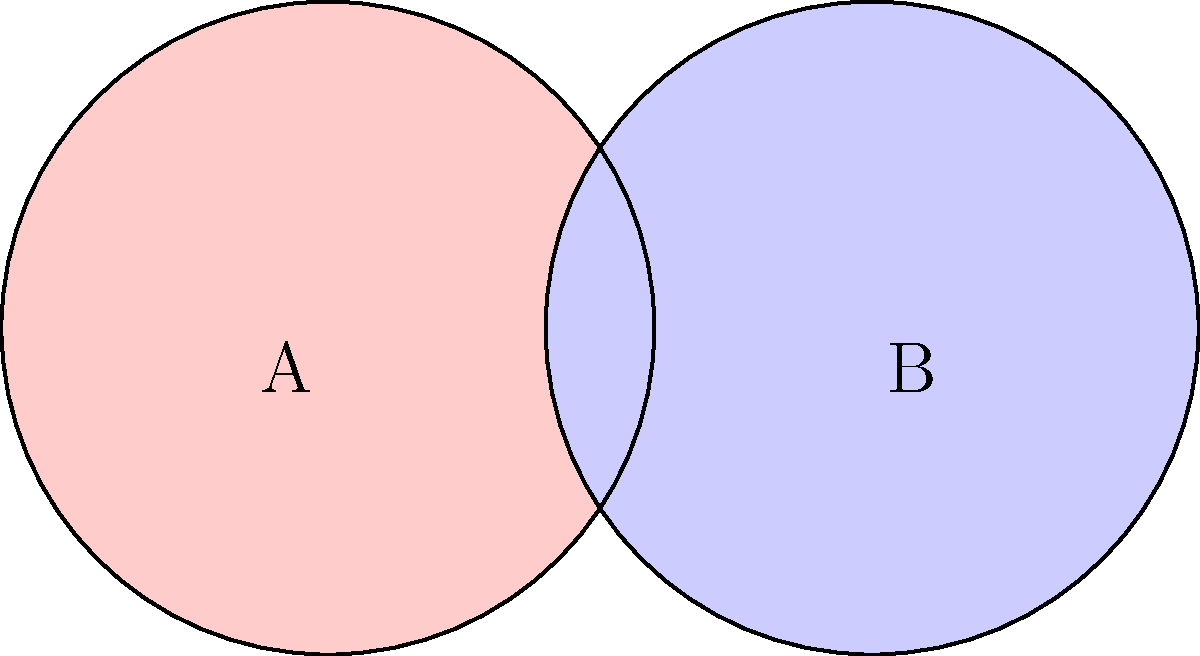In your latest art installation, you've created a Venn diagram using two overlapping circles of equal radius. If each circle represents a different aspect of Texan culture and has an area of 36π square inches, what is the area of the overlapping region (in square inches) where the two aspects intersect? Round your answer to the nearest whole number. Let's approach this step-by-step:

1) First, we need to find the radius of each circle. We know the area is 36π square inches.
   The formula for the area of a circle is $A = πr^2$
   So, $36π = πr^2$
   $r^2 = 36$
   $r = 6$ inches

2) Now, we need to find the distance between the centers of the circles. In a standard Venn diagram, this distance is equal to the radius. So the distance is also 6 inches.

3) To find the area of overlap, we can use the formula for the area of intersection of two circles:

   $A = 2r^2 \arccos(\frac{d}{2r}) - d\sqrt{r^2 - \frac{d^2}{4}}$

   Where $r$ is the radius and $d$ is the distance between centers.

4) Plugging in our values:
   $A = 2(6^2) \arccos(\frac{6}{2(6)}) - 6\sqrt{6^2 - \frac{6^2}{4}}$
   $= 72 \arccos(0.5) - 6\sqrt{36 - 9}$
   $= 72 \arccos(0.5) - 6\sqrt{27}$
   $= 72 (1.0472) - 6(5.1962)$
   $= 75.3984 - 31.1772$
   $= 44.2212$ square inches

5) Rounding to the nearest whole number: 44 square inches
Answer: 44 square inches 